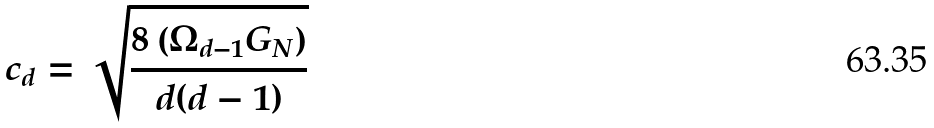Convert formula to latex. <formula><loc_0><loc_0><loc_500><loc_500>c _ { d } = \sqrt { \frac { 8 \left ( \Omega _ { d - 1 } G _ { N } \right ) } { d ( d - 1 ) } }</formula> 